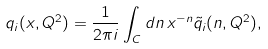<formula> <loc_0><loc_0><loc_500><loc_500>q _ { i } ( x , Q ^ { 2 } ) = \frac { 1 } { 2 \pi i } \int _ { C } d n \, x ^ { - n } \tilde { q } _ { i } ( n , Q ^ { 2 } ) ,</formula> 